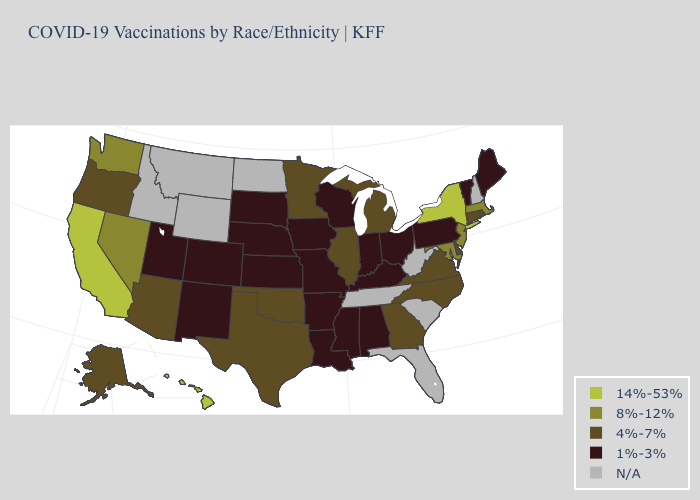What is the value of Virginia?
Answer briefly. 4%-7%. What is the value of Vermont?
Answer briefly. 1%-3%. Does Missouri have the highest value in the USA?
Quick response, please. No. What is the value of North Carolina?
Be succinct. 4%-7%. What is the value of Idaho?
Quick response, please. N/A. Does California have the highest value in the USA?
Answer briefly. Yes. Name the states that have a value in the range 8%-12%?
Write a very short answer. Maryland, Massachusetts, Nevada, New Jersey, Washington. Name the states that have a value in the range N/A?
Keep it brief. Florida, Idaho, Montana, New Hampshire, North Dakota, South Carolina, Tennessee, West Virginia, Wyoming. Among the states that border Oklahoma , does Texas have the lowest value?
Write a very short answer. No. How many symbols are there in the legend?
Quick response, please. 5. What is the value of West Virginia?
Be succinct. N/A. Does the first symbol in the legend represent the smallest category?
Be succinct. No. Name the states that have a value in the range 14%-53%?
Answer briefly. California, Hawaii, New York. 